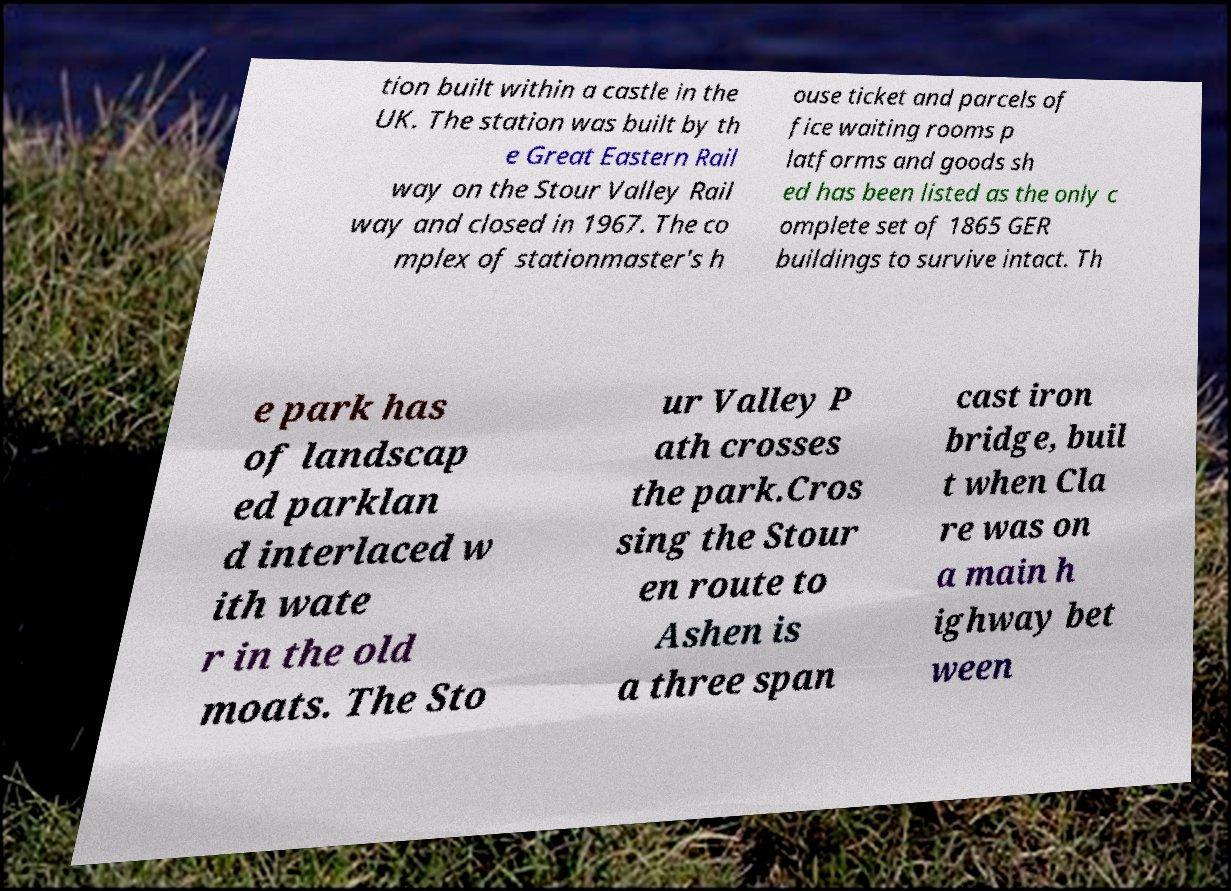Can you read and provide the text displayed in the image?This photo seems to have some interesting text. Can you extract and type it out for me? tion built within a castle in the UK. The station was built by th e Great Eastern Rail way on the Stour Valley Rail way and closed in 1967. The co mplex of stationmaster's h ouse ticket and parcels of fice waiting rooms p latforms and goods sh ed has been listed as the only c omplete set of 1865 GER buildings to survive intact. Th e park has of landscap ed parklan d interlaced w ith wate r in the old moats. The Sto ur Valley P ath crosses the park.Cros sing the Stour en route to Ashen is a three span cast iron bridge, buil t when Cla re was on a main h ighway bet ween 